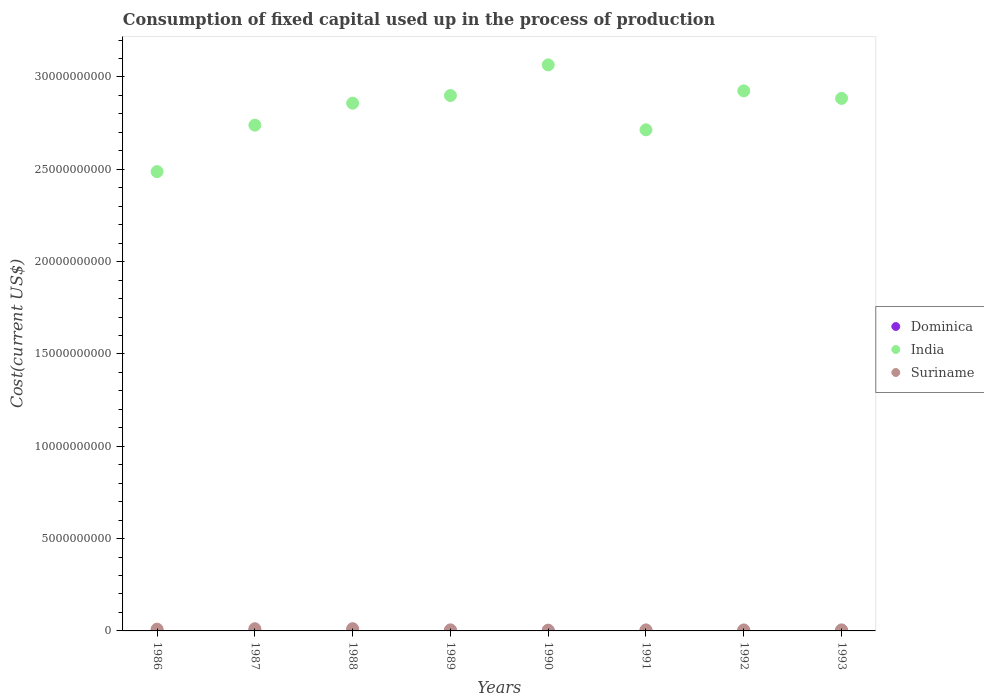How many different coloured dotlines are there?
Make the answer very short. 3. Is the number of dotlines equal to the number of legend labels?
Offer a very short reply. Yes. What is the amount consumed in the process of production in Suriname in 1989?
Your answer should be compact. 5.74e+07. Across all years, what is the maximum amount consumed in the process of production in Suriname?
Ensure brevity in your answer.  1.22e+08. Across all years, what is the minimum amount consumed in the process of production in Dominica?
Your answer should be compact. 4.17e+06. In which year was the amount consumed in the process of production in Suriname minimum?
Ensure brevity in your answer.  1990. What is the total amount consumed in the process of production in Dominica in the graph?
Your answer should be compact. 5.11e+07. What is the difference between the amount consumed in the process of production in India in 1990 and that in 1993?
Offer a terse response. 1.82e+09. What is the difference between the amount consumed in the process of production in India in 1986 and the amount consumed in the process of production in Suriname in 1990?
Give a very brief answer. 2.48e+1. What is the average amount consumed in the process of production in Dominica per year?
Your answer should be compact. 6.39e+06. In the year 1990, what is the difference between the amount consumed in the process of production in Suriname and amount consumed in the process of production in India?
Ensure brevity in your answer.  -3.06e+1. In how many years, is the amount consumed in the process of production in Suriname greater than 7000000000 US$?
Your response must be concise. 0. What is the ratio of the amount consumed in the process of production in Suriname in 1987 to that in 1992?
Provide a short and direct response. 2.21. What is the difference between the highest and the second highest amount consumed in the process of production in Dominica?
Ensure brevity in your answer.  5.16e+05. What is the difference between the highest and the lowest amount consumed in the process of production in Suriname?
Provide a short and direct response. 8.02e+07. Is it the case that in every year, the sum of the amount consumed in the process of production in Dominica and amount consumed in the process of production in India  is greater than the amount consumed in the process of production in Suriname?
Make the answer very short. Yes. Is the amount consumed in the process of production in India strictly greater than the amount consumed in the process of production in Suriname over the years?
Provide a short and direct response. Yes. Are the values on the major ticks of Y-axis written in scientific E-notation?
Make the answer very short. No. Does the graph contain grids?
Offer a terse response. No. Where does the legend appear in the graph?
Keep it short and to the point. Center right. How many legend labels are there?
Provide a succinct answer. 3. What is the title of the graph?
Offer a terse response. Consumption of fixed capital used up in the process of production. Does "Northern Mariana Islands" appear as one of the legend labels in the graph?
Offer a very short reply. No. What is the label or title of the X-axis?
Offer a very short reply. Years. What is the label or title of the Y-axis?
Your response must be concise. Cost(current US$). What is the Cost(current US$) of Dominica in 1986?
Your answer should be compact. 4.17e+06. What is the Cost(current US$) of India in 1986?
Offer a very short reply. 2.49e+1. What is the Cost(current US$) of Suriname in 1986?
Offer a terse response. 9.57e+07. What is the Cost(current US$) of Dominica in 1987?
Your answer should be compact. 4.59e+06. What is the Cost(current US$) in India in 1987?
Your response must be concise. 2.74e+1. What is the Cost(current US$) of Suriname in 1987?
Provide a short and direct response. 1.18e+08. What is the Cost(current US$) of Dominica in 1988?
Your answer should be very brief. 5.11e+06. What is the Cost(current US$) in India in 1988?
Your answer should be compact. 2.86e+1. What is the Cost(current US$) of Suriname in 1988?
Offer a terse response. 1.22e+08. What is the Cost(current US$) of Dominica in 1989?
Your answer should be compact. 5.78e+06. What is the Cost(current US$) of India in 1989?
Your answer should be compact. 2.90e+1. What is the Cost(current US$) of Suriname in 1989?
Make the answer very short. 5.74e+07. What is the Cost(current US$) in Dominica in 1990?
Provide a short and direct response. 6.67e+06. What is the Cost(current US$) in India in 1990?
Keep it short and to the point. 3.07e+1. What is the Cost(current US$) in Suriname in 1990?
Make the answer very short. 4.17e+07. What is the Cost(current US$) in Dominica in 1991?
Your answer should be very brief. 7.73e+06. What is the Cost(current US$) of India in 1991?
Provide a short and direct response. 2.71e+1. What is the Cost(current US$) in Suriname in 1991?
Give a very brief answer. 5.59e+07. What is the Cost(current US$) of Dominica in 1992?
Your response must be concise. 8.29e+06. What is the Cost(current US$) of India in 1992?
Keep it short and to the point. 2.92e+1. What is the Cost(current US$) of Suriname in 1992?
Offer a very short reply. 5.34e+07. What is the Cost(current US$) of Dominica in 1993?
Give a very brief answer. 8.80e+06. What is the Cost(current US$) in India in 1993?
Offer a very short reply. 2.88e+1. What is the Cost(current US$) of Suriname in 1993?
Your answer should be very brief. 5.61e+07. Across all years, what is the maximum Cost(current US$) in Dominica?
Ensure brevity in your answer.  8.80e+06. Across all years, what is the maximum Cost(current US$) of India?
Offer a very short reply. 3.07e+1. Across all years, what is the maximum Cost(current US$) of Suriname?
Provide a short and direct response. 1.22e+08. Across all years, what is the minimum Cost(current US$) in Dominica?
Provide a short and direct response. 4.17e+06. Across all years, what is the minimum Cost(current US$) in India?
Your answer should be very brief. 2.49e+1. Across all years, what is the minimum Cost(current US$) of Suriname?
Offer a very short reply. 4.17e+07. What is the total Cost(current US$) of Dominica in the graph?
Make the answer very short. 5.11e+07. What is the total Cost(current US$) of India in the graph?
Make the answer very short. 2.26e+11. What is the total Cost(current US$) in Suriname in the graph?
Keep it short and to the point. 6.00e+08. What is the difference between the Cost(current US$) of Dominica in 1986 and that in 1987?
Give a very brief answer. -4.29e+05. What is the difference between the Cost(current US$) of India in 1986 and that in 1987?
Offer a very short reply. -2.52e+09. What is the difference between the Cost(current US$) in Suriname in 1986 and that in 1987?
Give a very brief answer. -2.23e+07. What is the difference between the Cost(current US$) in Dominica in 1986 and that in 1988?
Your answer should be compact. -9.46e+05. What is the difference between the Cost(current US$) in India in 1986 and that in 1988?
Give a very brief answer. -3.71e+09. What is the difference between the Cost(current US$) in Suriname in 1986 and that in 1988?
Your response must be concise. -2.62e+07. What is the difference between the Cost(current US$) of Dominica in 1986 and that in 1989?
Provide a succinct answer. -1.61e+06. What is the difference between the Cost(current US$) of India in 1986 and that in 1989?
Make the answer very short. -4.12e+09. What is the difference between the Cost(current US$) of Suriname in 1986 and that in 1989?
Ensure brevity in your answer.  3.83e+07. What is the difference between the Cost(current US$) in Dominica in 1986 and that in 1990?
Your response must be concise. -2.50e+06. What is the difference between the Cost(current US$) of India in 1986 and that in 1990?
Your answer should be very brief. -5.78e+09. What is the difference between the Cost(current US$) in Suriname in 1986 and that in 1990?
Offer a very short reply. 5.40e+07. What is the difference between the Cost(current US$) of Dominica in 1986 and that in 1991?
Ensure brevity in your answer.  -3.56e+06. What is the difference between the Cost(current US$) of India in 1986 and that in 1991?
Your response must be concise. -2.26e+09. What is the difference between the Cost(current US$) in Suriname in 1986 and that in 1991?
Your answer should be very brief. 3.99e+07. What is the difference between the Cost(current US$) of Dominica in 1986 and that in 1992?
Your answer should be compact. -4.12e+06. What is the difference between the Cost(current US$) of India in 1986 and that in 1992?
Offer a very short reply. -4.37e+09. What is the difference between the Cost(current US$) of Suriname in 1986 and that in 1992?
Your answer should be very brief. 4.23e+07. What is the difference between the Cost(current US$) in Dominica in 1986 and that in 1993?
Keep it short and to the point. -4.64e+06. What is the difference between the Cost(current US$) of India in 1986 and that in 1993?
Offer a terse response. -3.97e+09. What is the difference between the Cost(current US$) in Suriname in 1986 and that in 1993?
Give a very brief answer. 3.97e+07. What is the difference between the Cost(current US$) in Dominica in 1987 and that in 1988?
Your answer should be very brief. -5.17e+05. What is the difference between the Cost(current US$) in India in 1987 and that in 1988?
Your response must be concise. -1.19e+09. What is the difference between the Cost(current US$) in Suriname in 1987 and that in 1988?
Make the answer very short. -3.94e+06. What is the difference between the Cost(current US$) in Dominica in 1987 and that in 1989?
Keep it short and to the point. -1.18e+06. What is the difference between the Cost(current US$) in India in 1987 and that in 1989?
Give a very brief answer. -1.60e+09. What is the difference between the Cost(current US$) in Suriname in 1987 and that in 1989?
Provide a succinct answer. 6.06e+07. What is the difference between the Cost(current US$) of Dominica in 1987 and that in 1990?
Keep it short and to the point. -2.07e+06. What is the difference between the Cost(current US$) in India in 1987 and that in 1990?
Give a very brief answer. -3.26e+09. What is the difference between the Cost(current US$) of Suriname in 1987 and that in 1990?
Your answer should be compact. 7.63e+07. What is the difference between the Cost(current US$) of Dominica in 1987 and that in 1991?
Offer a very short reply. -3.13e+06. What is the difference between the Cost(current US$) in India in 1987 and that in 1991?
Give a very brief answer. 2.53e+08. What is the difference between the Cost(current US$) of Suriname in 1987 and that in 1991?
Your answer should be very brief. 6.21e+07. What is the difference between the Cost(current US$) of Dominica in 1987 and that in 1992?
Offer a very short reply. -3.69e+06. What is the difference between the Cost(current US$) of India in 1987 and that in 1992?
Your answer should be very brief. -1.86e+09. What is the difference between the Cost(current US$) in Suriname in 1987 and that in 1992?
Ensure brevity in your answer.  6.46e+07. What is the difference between the Cost(current US$) in Dominica in 1987 and that in 1993?
Your response must be concise. -4.21e+06. What is the difference between the Cost(current US$) in India in 1987 and that in 1993?
Provide a short and direct response. -1.45e+09. What is the difference between the Cost(current US$) of Suriname in 1987 and that in 1993?
Keep it short and to the point. 6.19e+07. What is the difference between the Cost(current US$) in Dominica in 1988 and that in 1989?
Provide a short and direct response. -6.66e+05. What is the difference between the Cost(current US$) of India in 1988 and that in 1989?
Provide a succinct answer. -4.14e+08. What is the difference between the Cost(current US$) of Suriname in 1988 and that in 1989?
Provide a succinct answer. 6.45e+07. What is the difference between the Cost(current US$) of Dominica in 1988 and that in 1990?
Provide a succinct answer. -1.56e+06. What is the difference between the Cost(current US$) of India in 1988 and that in 1990?
Provide a short and direct response. -2.07e+09. What is the difference between the Cost(current US$) in Suriname in 1988 and that in 1990?
Give a very brief answer. 8.02e+07. What is the difference between the Cost(current US$) in Dominica in 1988 and that in 1991?
Your answer should be very brief. -2.61e+06. What is the difference between the Cost(current US$) in India in 1988 and that in 1991?
Provide a succinct answer. 1.44e+09. What is the difference between the Cost(current US$) of Suriname in 1988 and that in 1991?
Offer a terse response. 6.61e+07. What is the difference between the Cost(current US$) of Dominica in 1988 and that in 1992?
Provide a short and direct response. -3.17e+06. What is the difference between the Cost(current US$) in India in 1988 and that in 1992?
Provide a short and direct response. -6.66e+08. What is the difference between the Cost(current US$) of Suriname in 1988 and that in 1992?
Offer a terse response. 6.85e+07. What is the difference between the Cost(current US$) of Dominica in 1988 and that in 1993?
Provide a succinct answer. -3.69e+06. What is the difference between the Cost(current US$) in India in 1988 and that in 1993?
Keep it short and to the point. -2.58e+08. What is the difference between the Cost(current US$) in Suriname in 1988 and that in 1993?
Provide a succinct answer. 6.59e+07. What is the difference between the Cost(current US$) of Dominica in 1989 and that in 1990?
Provide a short and direct response. -8.90e+05. What is the difference between the Cost(current US$) in India in 1989 and that in 1990?
Make the answer very short. -1.66e+09. What is the difference between the Cost(current US$) in Suriname in 1989 and that in 1990?
Your answer should be compact. 1.57e+07. What is the difference between the Cost(current US$) in Dominica in 1989 and that in 1991?
Provide a succinct answer. -1.95e+06. What is the difference between the Cost(current US$) of India in 1989 and that in 1991?
Keep it short and to the point. 1.86e+09. What is the difference between the Cost(current US$) of Suriname in 1989 and that in 1991?
Your answer should be very brief. 1.56e+06. What is the difference between the Cost(current US$) of Dominica in 1989 and that in 1992?
Provide a short and direct response. -2.51e+06. What is the difference between the Cost(current US$) of India in 1989 and that in 1992?
Provide a succinct answer. -2.52e+08. What is the difference between the Cost(current US$) of Suriname in 1989 and that in 1992?
Provide a short and direct response. 4.01e+06. What is the difference between the Cost(current US$) of Dominica in 1989 and that in 1993?
Offer a very short reply. -3.02e+06. What is the difference between the Cost(current US$) of India in 1989 and that in 1993?
Your answer should be very brief. 1.55e+08. What is the difference between the Cost(current US$) of Suriname in 1989 and that in 1993?
Keep it short and to the point. 1.36e+06. What is the difference between the Cost(current US$) of Dominica in 1990 and that in 1991?
Your response must be concise. -1.06e+06. What is the difference between the Cost(current US$) of India in 1990 and that in 1991?
Ensure brevity in your answer.  3.52e+09. What is the difference between the Cost(current US$) of Suriname in 1990 and that in 1991?
Give a very brief answer. -1.41e+07. What is the difference between the Cost(current US$) in Dominica in 1990 and that in 1992?
Offer a terse response. -1.62e+06. What is the difference between the Cost(current US$) of India in 1990 and that in 1992?
Keep it short and to the point. 1.41e+09. What is the difference between the Cost(current US$) of Suriname in 1990 and that in 1992?
Make the answer very short. -1.17e+07. What is the difference between the Cost(current US$) of Dominica in 1990 and that in 1993?
Ensure brevity in your answer.  -2.13e+06. What is the difference between the Cost(current US$) in India in 1990 and that in 1993?
Provide a succinct answer. 1.82e+09. What is the difference between the Cost(current US$) in Suriname in 1990 and that in 1993?
Your answer should be very brief. -1.43e+07. What is the difference between the Cost(current US$) of Dominica in 1991 and that in 1992?
Give a very brief answer. -5.60e+05. What is the difference between the Cost(current US$) of India in 1991 and that in 1992?
Give a very brief answer. -2.11e+09. What is the difference between the Cost(current US$) in Suriname in 1991 and that in 1992?
Ensure brevity in your answer.  2.45e+06. What is the difference between the Cost(current US$) in Dominica in 1991 and that in 1993?
Keep it short and to the point. -1.08e+06. What is the difference between the Cost(current US$) in India in 1991 and that in 1993?
Make the answer very short. -1.70e+09. What is the difference between the Cost(current US$) in Suriname in 1991 and that in 1993?
Offer a very short reply. -1.99e+05. What is the difference between the Cost(current US$) in Dominica in 1992 and that in 1993?
Provide a succinct answer. -5.16e+05. What is the difference between the Cost(current US$) of India in 1992 and that in 1993?
Provide a succinct answer. 4.08e+08. What is the difference between the Cost(current US$) in Suriname in 1992 and that in 1993?
Your response must be concise. -2.65e+06. What is the difference between the Cost(current US$) of Dominica in 1986 and the Cost(current US$) of India in 1987?
Offer a terse response. -2.74e+1. What is the difference between the Cost(current US$) of Dominica in 1986 and the Cost(current US$) of Suriname in 1987?
Your response must be concise. -1.14e+08. What is the difference between the Cost(current US$) of India in 1986 and the Cost(current US$) of Suriname in 1987?
Make the answer very short. 2.48e+1. What is the difference between the Cost(current US$) in Dominica in 1986 and the Cost(current US$) in India in 1988?
Offer a terse response. -2.86e+1. What is the difference between the Cost(current US$) in Dominica in 1986 and the Cost(current US$) in Suriname in 1988?
Your response must be concise. -1.18e+08. What is the difference between the Cost(current US$) of India in 1986 and the Cost(current US$) of Suriname in 1988?
Provide a succinct answer. 2.48e+1. What is the difference between the Cost(current US$) in Dominica in 1986 and the Cost(current US$) in India in 1989?
Offer a very short reply. -2.90e+1. What is the difference between the Cost(current US$) in Dominica in 1986 and the Cost(current US$) in Suriname in 1989?
Your answer should be very brief. -5.33e+07. What is the difference between the Cost(current US$) in India in 1986 and the Cost(current US$) in Suriname in 1989?
Make the answer very short. 2.48e+1. What is the difference between the Cost(current US$) of Dominica in 1986 and the Cost(current US$) of India in 1990?
Offer a terse response. -3.07e+1. What is the difference between the Cost(current US$) in Dominica in 1986 and the Cost(current US$) in Suriname in 1990?
Ensure brevity in your answer.  -3.76e+07. What is the difference between the Cost(current US$) of India in 1986 and the Cost(current US$) of Suriname in 1990?
Provide a short and direct response. 2.48e+1. What is the difference between the Cost(current US$) of Dominica in 1986 and the Cost(current US$) of India in 1991?
Offer a very short reply. -2.71e+1. What is the difference between the Cost(current US$) in Dominica in 1986 and the Cost(current US$) in Suriname in 1991?
Provide a short and direct response. -5.17e+07. What is the difference between the Cost(current US$) of India in 1986 and the Cost(current US$) of Suriname in 1991?
Offer a very short reply. 2.48e+1. What is the difference between the Cost(current US$) in Dominica in 1986 and the Cost(current US$) in India in 1992?
Your answer should be very brief. -2.92e+1. What is the difference between the Cost(current US$) of Dominica in 1986 and the Cost(current US$) of Suriname in 1992?
Make the answer very short. -4.93e+07. What is the difference between the Cost(current US$) of India in 1986 and the Cost(current US$) of Suriname in 1992?
Provide a short and direct response. 2.48e+1. What is the difference between the Cost(current US$) in Dominica in 1986 and the Cost(current US$) in India in 1993?
Provide a short and direct response. -2.88e+1. What is the difference between the Cost(current US$) of Dominica in 1986 and the Cost(current US$) of Suriname in 1993?
Ensure brevity in your answer.  -5.19e+07. What is the difference between the Cost(current US$) in India in 1986 and the Cost(current US$) in Suriname in 1993?
Ensure brevity in your answer.  2.48e+1. What is the difference between the Cost(current US$) of Dominica in 1987 and the Cost(current US$) of India in 1988?
Make the answer very short. -2.86e+1. What is the difference between the Cost(current US$) in Dominica in 1987 and the Cost(current US$) in Suriname in 1988?
Make the answer very short. -1.17e+08. What is the difference between the Cost(current US$) in India in 1987 and the Cost(current US$) in Suriname in 1988?
Your answer should be very brief. 2.73e+1. What is the difference between the Cost(current US$) of Dominica in 1987 and the Cost(current US$) of India in 1989?
Your answer should be very brief. -2.90e+1. What is the difference between the Cost(current US$) of Dominica in 1987 and the Cost(current US$) of Suriname in 1989?
Offer a very short reply. -5.29e+07. What is the difference between the Cost(current US$) in India in 1987 and the Cost(current US$) in Suriname in 1989?
Provide a succinct answer. 2.73e+1. What is the difference between the Cost(current US$) of Dominica in 1987 and the Cost(current US$) of India in 1990?
Keep it short and to the point. -3.07e+1. What is the difference between the Cost(current US$) in Dominica in 1987 and the Cost(current US$) in Suriname in 1990?
Ensure brevity in your answer.  -3.71e+07. What is the difference between the Cost(current US$) in India in 1987 and the Cost(current US$) in Suriname in 1990?
Make the answer very short. 2.73e+1. What is the difference between the Cost(current US$) of Dominica in 1987 and the Cost(current US$) of India in 1991?
Provide a short and direct response. -2.71e+1. What is the difference between the Cost(current US$) in Dominica in 1987 and the Cost(current US$) in Suriname in 1991?
Give a very brief answer. -5.13e+07. What is the difference between the Cost(current US$) of India in 1987 and the Cost(current US$) of Suriname in 1991?
Offer a very short reply. 2.73e+1. What is the difference between the Cost(current US$) of Dominica in 1987 and the Cost(current US$) of India in 1992?
Provide a succinct answer. -2.92e+1. What is the difference between the Cost(current US$) in Dominica in 1987 and the Cost(current US$) in Suriname in 1992?
Give a very brief answer. -4.88e+07. What is the difference between the Cost(current US$) in India in 1987 and the Cost(current US$) in Suriname in 1992?
Provide a succinct answer. 2.73e+1. What is the difference between the Cost(current US$) of Dominica in 1987 and the Cost(current US$) of India in 1993?
Your answer should be compact. -2.88e+1. What is the difference between the Cost(current US$) of Dominica in 1987 and the Cost(current US$) of Suriname in 1993?
Ensure brevity in your answer.  -5.15e+07. What is the difference between the Cost(current US$) in India in 1987 and the Cost(current US$) in Suriname in 1993?
Your answer should be very brief. 2.73e+1. What is the difference between the Cost(current US$) in Dominica in 1988 and the Cost(current US$) in India in 1989?
Give a very brief answer. -2.90e+1. What is the difference between the Cost(current US$) of Dominica in 1988 and the Cost(current US$) of Suriname in 1989?
Give a very brief answer. -5.23e+07. What is the difference between the Cost(current US$) of India in 1988 and the Cost(current US$) of Suriname in 1989?
Ensure brevity in your answer.  2.85e+1. What is the difference between the Cost(current US$) of Dominica in 1988 and the Cost(current US$) of India in 1990?
Your answer should be very brief. -3.07e+1. What is the difference between the Cost(current US$) in Dominica in 1988 and the Cost(current US$) in Suriname in 1990?
Your response must be concise. -3.66e+07. What is the difference between the Cost(current US$) of India in 1988 and the Cost(current US$) of Suriname in 1990?
Offer a very short reply. 2.85e+1. What is the difference between the Cost(current US$) in Dominica in 1988 and the Cost(current US$) in India in 1991?
Give a very brief answer. -2.71e+1. What is the difference between the Cost(current US$) of Dominica in 1988 and the Cost(current US$) of Suriname in 1991?
Your answer should be very brief. -5.08e+07. What is the difference between the Cost(current US$) of India in 1988 and the Cost(current US$) of Suriname in 1991?
Provide a short and direct response. 2.85e+1. What is the difference between the Cost(current US$) of Dominica in 1988 and the Cost(current US$) of India in 1992?
Your answer should be compact. -2.92e+1. What is the difference between the Cost(current US$) in Dominica in 1988 and the Cost(current US$) in Suriname in 1992?
Ensure brevity in your answer.  -4.83e+07. What is the difference between the Cost(current US$) in India in 1988 and the Cost(current US$) in Suriname in 1992?
Give a very brief answer. 2.85e+1. What is the difference between the Cost(current US$) in Dominica in 1988 and the Cost(current US$) in India in 1993?
Keep it short and to the point. -2.88e+1. What is the difference between the Cost(current US$) of Dominica in 1988 and the Cost(current US$) of Suriname in 1993?
Your response must be concise. -5.10e+07. What is the difference between the Cost(current US$) of India in 1988 and the Cost(current US$) of Suriname in 1993?
Keep it short and to the point. 2.85e+1. What is the difference between the Cost(current US$) of Dominica in 1989 and the Cost(current US$) of India in 1990?
Provide a succinct answer. -3.07e+1. What is the difference between the Cost(current US$) of Dominica in 1989 and the Cost(current US$) of Suriname in 1990?
Offer a terse response. -3.60e+07. What is the difference between the Cost(current US$) of India in 1989 and the Cost(current US$) of Suriname in 1990?
Offer a very short reply. 2.90e+1. What is the difference between the Cost(current US$) in Dominica in 1989 and the Cost(current US$) in India in 1991?
Make the answer very short. -2.71e+1. What is the difference between the Cost(current US$) of Dominica in 1989 and the Cost(current US$) of Suriname in 1991?
Provide a short and direct response. -5.01e+07. What is the difference between the Cost(current US$) in India in 1989 and the Cost(current US$) in Suriname in 1991?
Your answer should be very brief. 2.89e+1. What is the difference between the Cost(current US$) in Dominica in 1989 and the Cost(current US$) in India in 1992?
Ensure brevity in your answer.  -2.92e+1. What is the difference between the Cost(current US$) of Dominica in 1989 and the Cost(current US$) of Suriname in 1992?
Provide a short and direct response. -4.77e+07. What is the difference between the Cost(current US$) in India in 1989 and the Cost(current US$) in Suriname in 1992?
Your answer should be very brief. 2.89e+1. What is the difference between the Cost(current US$) in Dominica in 1989 and the Cost(current US$) in India in 1993?
Provide a succinct answer. -2.88e+1. What is the difference between the Cost(current US$) of Dominica in 1989 and the Cost(current US$) of Suriname in 1993?
Your answer should be very brief. -5.03e+07. What is the difference between the Cost(current US$) of India in 1989 and the Cost(current US$) of Suriname in 1993?
Your answer should be very brief. 2.89e+1. What is the difference between the Cost(current US$) of Dominica in 1990 and the Cost(current US$) of India in 1991?
Provide a succinct answer. -2.71e+1. What is the difference between the Cost(current US$) in Dominica in 1990 and the Cost(current US$) in Suriname in 1991?
Your answer should be very brief. -4.92e+07. What is the difference between the Cost(current US$) of India in 1990 and the Cost(current US$) of Suriname in 1991?
Offer a very short reply. 3.06e+1. What is the difference between the Cost(current US$) of Dominica in 1990 and the Cost(current US$) of India in 1992?
Your answer should be very brief. -2.92e+1. What is the difference between the Cost(current US$) in Dominica in 1990 and the Cost(current US$) in Suriname in 1992?
Give a very brief answer. -4.68e+07. What is the difference between the Cost(current US$) of India in 1990 and the Cost(current US$) of Suriname in 1992?
Your answer should be very brief. 3.06e+1. What is the difference between the Cost(current US$) in Dominica in 1990 and the Cost(current US$) in India in 1993?
Give a very brief answer. -2.88e+1. What is the difference between the Cost(current US$) in Dominica in 1990 and the Cost(current US$) in Suriname in 1993?
Keep it short and to the point. -4.94e+07. What is the difference between the Cost(current US$) of India in 1990 and the Cost(current US$) of Suriname in 1993?
Keep it short and to the point. 3.06e+1. What is the difference between the Cost(current US$) in Dominica in 1991 and the Cost(current US$) in India in 1992?
Offer a very short reply. -2.92e+1. What is the difference between the Cost(current US$) of Dominica in 1991 and the Cost(current US$) of Suriname in 1992?
Offer a terse response. -4.57e+07. What is the difference between the Cost(current US$) of India in 1991 and the Cost(current US$) of Suriname in 1992?
Keep it short and to the point. 2.71e+1. What is the difference between the Cost(current US$) of Dominica in 1991 and the Cost(current US$) of India in 1993?
Provide a succinct answer. -2.88e+1. What is the difference between the Cost(current US$) in Dominica in 1991 and the Cost(current US$) in Suriname in 1993?
Provide a succinct answer. -4.84e+07. What is the difference between the Cost(current US$) of India in 1991 and the Cost(current US$) of Suriname in 1993?
Ensure brevity in your answer.  2.71e+1. What is the difference between the Cost(current US$) in Dominica in 1992 and the Cost(current US$) in India in 1993?
Your answer should be compact. -2.88e+1. What is the difference between the Cost(current US$) of Dominica in 1992 and the Cost(current US$) of Suriname in 1993?
Make the answer very short. -4.78e+07. What is the difference between the Cost(current US$) in India in 1992 and the Cost(current US$) in Suriname in 1993?
Ensure brevity in your answer.  2.92e+1. What is the average Cost(current US$) of Dominica per year?
Ensure brevity in your answer.  6.39e+06. What is the average Cost(current US$) of India per year?
Provide a short and direct response. 2.82e+1. What is the average Cost(current US$) of Suriname per year?
Your response must be concise. 7.50e+07. In the year 1986, what is the difference between the Cost(current US$) in Dominica and Cost(current US$) in India?
Keep it short and to the point. -2.49e+1. In the year 1986, what is the difference between the Cost(current US$) in Dominica and Cost(current US$) in Suriname?
Your answer should be compact. -9.16e+07. In the year 1986, what is the difference between the Cost(current US$) in India and Cost(current US$) in Suriname?
Your answer should be very brief. 2.48e+1. In the year 1987, what is the difference between the Cost(current US$) of Dominica and Cost(current US$) of India?
Your answer should be very brief. -2.74e+1. In the year 1987, what is the difference between the Cost(current US$) in Dominica and Cost(current US$) in Suriname?
Make the answer very short. -1.13e+08. In the year 1987, what is the difference between the Cost(current US$) in India and Cost(current US$) in Suriname?
Offer a very short reply. 2.73e+1. In the year 1988, what is the difference between the Cost(current US$) in Dominica and Cost(current US$) in India?
Your answer should be very brief. -2.86e+1. In the year 1988, what is the difference between the Cost(current US$) in Dominica and Cost(current US$) in Suriname?
Your answer should be compact. -1.17e+08. In the year 1988, what is the difference between the Cost(current US$) in India and Cost(current US$) in Suriname?
Offer a very short reply. 2.85e+1. In the year 1989, what is the difference between the Cost(current US$) of Dominica and Cost(current US$) of India?
Provide a short and direct response. -2.90e+1. In the year 1989, what is the difference between the Cost(current US$) of Dominica and Cost(current US$) of Suriname?
Offer a very short reply. -5.17e+07. In the year 1989, what is the difference between the Cost(current US$) in India and Cost(current US$) in Suriname?
Make the answer very short. 2.89e+1. In the year 1990, what is the difference between the Cost(current US$) in Dominica and Cost(current US$) in India?
Your answer should be very brief. -3.06e+1. In the year 1990, what is the difference between the Cost(current US$) in Dominica and Cost(current US$) in Suriname?
Make the answer very short. -3.51e+07. In the year 1990, what is the difference between the Cost(current US$) in India and Cost(current US$) in Suriname?
Give a very brief answer. 3.06e+1. In the year 1991, what is the difference between the Cost(current US$) in Dominica and Cost(current US$) in India?
Your response must be concise. -2.71e+1. In the year 1991, what is the difference between the Cost(current US$) in Dominica and Cost(current US$) in Suriname?
Ensure brevity in your answer.  -4.82e+07. In the year 1991, what is the difference between the Cost(current US$) in India and Cost(current US$) in Suriname?
Your answer should be very brief. 2.71e+1. In the year 1992, what is the difference between the Cost(current US$) in Dominica and Cost(current US$) in India?
Your response must be concise. -2.92e+1. In the year 1992, what is the difference between the Cost(current US$) of Dominica and Cost(current US$) of Suriname?
Your response must be concise. -4.51e+07. In the year 1992, what is the difference between the Cost(current US$) in India and Cost(current US$) in Suriname?
Your answer should be compact. 2.92e+1. In the year 1993, what is the difference between the Cost(current US$) of Dominica and Cost(current US$) of India?
Provide a short and direct response. -2.88e+1. In the year 1993, what is the difference between the Cost(current US$) of Dominica and Cost(current US$) of Suriname?
Provide a short and direct response. -4.73e+07. In the year 1993, what is the difference between the Cost(current US$) of India and Cost(current US$) of Suriname?
Make the answer very short. 2.88e+1. What is the ratio of the Cost(current US$) in Dominica in 1986 to that in 1987?
Offer a terse response. 0.91. What is the ratio of the Cost(current US$) of India in 1986 to that in 1987?
Provide a succinct answer. 0.91. What is the ratio of the Cost(current US$) of Suriname in 1986 to that in 1987?
Ensure brevity in your answer.  0.81. What is the ratio of the Cost(current US$) of Dominica in 1986 to that in 1988?
Your answer should be compact. 0.81. What is the ratio of the Cost(current US$) of India in 1986 to that in 1988?
Give a very brief answer. 0.87. What is the ratio of the Cost(current US$) of Suriname in 1986 to that in 1988?
Make the answer very short. 0.79. What is the ratio of the Cost(current US$) of Dominica in 1986 to that in 1989?
Offer a terse response. 0.72. What is the ratio of the Cost(current US$) of India in 1986 to that in 1989?
Provide a short and direct response. 0.86. What is the ratio of the Cost(current US$) of Suriname in 1986 to that in 1989?
Offer a terse response. 1.67. What is the ratio of the Cost(current US$) of Dominica in 1986 to that in 1990?
Give a very brief answer. 0.62. What is the ratio of the Cost(current US$) in India in 1986 to that in 1990?
Give a very brief answer. 0.81. What is the ratio of the Cost(current US$) in Suriname in 1986 to that in 1990?
Provide a short and direct response. 2.29. What is the ratio of the Cost(current US$) of Dominica in 1986 to that in 1991?
Your response must be concise. 0.54. What is the ratio of the Cost(current US$) in India in 1986 to that in 1991?
Ensure brevity in your answer.  0.92. What is the ratio of the Cost(current US$) of Suriname in 1986 to that in 1991?
Your answer should be very brief. 1.71. What is the ratio of the Cost(current US$) of Dominica in 1986 to that in 1992?
Ensure brevity in your answer.  0.5. What is the ratio of the Cost(current US$) in India in 1986 to that in 1992?
Ensure brevity in your answer.  0.85. What is the ratio of the Cost(current US$) in Suriname in 1986 to that in 1992?
Your answer should be very brief. 1.79. What is the ratio of the Cost(current US$) in Dominica in 1986 to that in 1993?
Make the answer very short. 0.47. What is the ratio of the Cost(current US$) of India in 1986 to that in 1993?
Your response must be concise. 0.86. What is the ratio of the Cost(current US$) of Suriname in 1986 to that in 1993?
Your response must be concise. 1.71. What is the ratio of the Cost(current US$) in Dominica in 1987 to that in 1988?
Offer a terse response. 0.9. What is the ratio of the Cost(current US$) in India in 1987 to that in 1988?
Give a very brief answer. 0.96. What is the ratio of the Cost(current US$) in Suriname in 1987 to that in 1988?
Offer a terse response. 0.97. What is the ratio of the Cost(current US$) of Dominica in 1987 to that in 1989?
Offer a terse response. 0.8. What is the ratio of the Cost(current US$) in India in 1987 to that in 1989?
Offer a very short reply. 0.94. What is the ratio of the Cost(current US$) in Suriname in 1987 to that in 1989?
Offer a very short reply. 2.05. What is the ratio of the Cost(current US$) in Dominica in 1987 to that in 1990?
Provide a short and direct response. 0.69. What is the ratio of the Cost(current US$) of India in 1987 to that in 1990?
Ensure brevity in your answer.  0.89. What is the ratio of the Cost(current US$) in Suriname in 1987 to that in 1990?
Ensure brevity in your answer.  2.83. What is the ratio of the Cost(current US$) of Dominica in 1987 to that in 1991?
Make the answer very short. 0.59. What is the ratio of the Cost(current US$) in India in 1987 to that in 1991?
Provide a succinct answer. 1.01. What is the ratio of the Cost(current US$) in Suriname in 1987 to that in 1991?
Offer a very short reply. 2.11. What is the ratio of the Cost(current US$) of Dominica in 1987 to that in 1992?
Your response must be concise. 0.55. What is the ratio of the Cost(current US$) in India in 1987 to that in 1992?
Give a very brief answer. 0.94. What is the ratio of the Cost(current US$) of Suriname in 1987 to that in 1992?
Offer a very short reply. 2.21. What is the ratio of the Cost(current US$) in Dominica in 1987 to that in 1993?
Your response must be concise. 0.52. What is the ratio of the Cost(current US$) of India in 1987 to that in 1993?
Offer a very short reply. 0.95. What is the ratio of the Cost(current US$) in Suriname in 1987 to that in 1993?
Provide a short and direct response. 2.1. What is the ratio of the Cost(current US$) of Dominica in 1988 to that in 1989?
Give a very brief answer. 0.88. What is the ratio of the Cost(current US$) of India in 1988 to that in 1989?
Make the answer very short. 0.99. What is the ratio of the Cost(current US$) of Suriname in 1988 to that in 1989?
Provide a succinct answer. 2.12. What is the ratio of the Cost(current US$) of Dominica in 1988 to that in 1990?
Provide a succinct answer. 0.77. What is the ratio of the Cost(current US$) of India in 1988 to that in 1990?
Ensure brevity in your answer.  0.93. What is the ratio of the Cost(current US$) of Suriname in 1988 to that in 1990?
Keep it short and to the point. 2.92. What is the ratio of the Cost(current US$) of Dominica in 1988 to that in 1991?
Your answer should be very brief. 0.66. What is the ratio of the Cost(current US$) in India in 1988 to that in 1991?
Keep it short and to the point. 1.05. What is the ratio of the Cost(current US$) of Suriname in 1988 to that in 1991?
Your response must be concise. 2.18. What is the ratio of the Cost(current US$) of Dominica in 1988 to that in 1992?
Make the answer very short. 0.62. What is the ratio of the Cost(current US$) in India in 1988 to that in 1992?
Offer a very short reply. 0.98. What is the ratio of the Cost(current US$) of Suriname in 1988 to that in 1992?
Keep it short and to the point. 2.28. What is the ratio of the Cost(current US$) in Dominica in 1988 to that in 1993?
Keep it short and to the point. 0.58. What is the ratio of the Cost(current US$) of Suriname in 1988 to that in 1993?
Keep it short and to the point. 2.17. What is the ratio of the Cost(current US$) of Dominica in 1989 to that in 1990?
Ensure brevity in your answer.  0.87. What is the ratio of the Cost(current US$) in India in 1989 to that in 1990?
Your answer should be very brief. 0.95. What is the ratio of the Cost(current US$) in Suriname in 1989 to that in 1990?
Offer a very short reply. 1.38. What is the ratio of the Cost(current US$) in Dominica in 1989 to that in 1991?
Provide a short and direct response. 0.75. What is the ratio of the Cost(current US$) in India in 1989 to that in 1991?
Offer a terse response. 1.07. What is the ratio of the Cost(current US$) of Suriname in 1989 to that in 1991?
Your response must be concise. 1.03. What is the ratio of the Cost(current US$) in Dominica in 1989 to that in 1992?
Ensure brevity in your answer.  0.7. What is the ratio of the Cost(current US$) in Suriname in 1989 to that in 1992?
Make the answer very short. 1.08. What is the ratio of the Cost(current US$) of Dominica in 1989 to that in 1993?
Your answer should be compact. 0.66. What is the ratio of the Cost(current US$) in India in 1989 to that in 1993?
Your answer should be very brief. 1.01. What is the ratio of the Cost(current US$) in Suriname in 1989 to that in 1993?
Give a very brief answer. 1.02. What is the ratio of the Cost(current US$) of Dominica in 1990 to that in 1991?
Make the answer very short. 0.86. What is the ratio of the Cost(current US$) of India in 1990 to that in 1991?
Offer a very short reply. 1.13. What is the ratio of the Cost(current US$) in Suriname in 1990 to that in 1991?
Offer a terse response. 0.75. What is the ratio of the Cost(current US$) in Dominica in 1990 to that in 1992?
Offer a very short reply. 0.8. What is the ratio of the Cost(current US$) of India in 1990 to that in 1992?
Give a very brief answer. 1.05. What is the ratio of the Cost(current US$) in Suriname in 1990 to that in 1992?
Your answer should be very brief. 0.78. What is the ratio of the Cost(current US$) in Dominica in 1990 to that in 1993?
Offer a terse response. 0.76. What is the ratio of the Cost(current US$) of India in 1990 to that in 1993?
Offer a very short reply. 1.06. What is the ratio of the Cost(current US$) of Suriname in 1990 to that in 1993?
Provide a short and direct response. 0.74. What is the ratio of the Cost(current US$) in Dominica in 1991 to that in 1992?
Give a very brief answer. 0.93. What is the ratio of the Cost(current US$) in India in 1991 to that in 1992?
Make the answer very short. 0.93. What is the ratio of the Cost(current US$) in Suriname in 1991 to that in 1992?
Give a very brief answer. 1.05. What is the ratio of the Cost(current US$) of Dominica in 1991 to that in 1993?
Offer a very short reply. 0.88. What is the ratio of the Cost(current US$) of India in 1991 to that in 1993?
Provide a short and direct response. 0.94. What is the ratio of the Cost(current US$) in Suriname in 1991 to that in 1993?
Provide a succinct answer. 1. What is the ratio of the Cost(current US$) in Dominica in 1992 to that in 1993?
Provide a succinct answer. 0.94. What is the ratio of the Cost(current US$) of India in 1992 to that in 1993?
Ensure brevity in your answer.  1.01. What is the ratio of the Cost(current US$) in Suriname in 1992 to that in 1993?
Offer a very short reply. 0.95. What is the difference between the highest and the second highest Cost(current US$) of Dominica?
Give a very brief answer. 5.16e+05. What is the difference between the highest and the second highest Cost(current US$) of India?
Provide a short and direct response. 1.41e+09. What is the difference between the highest and the second highest Cost(current US$) of Suriname?
Offer a very short reply. 3.94e+06. What is the difference between the highest and the lowest Cost(current US$) of Dominica?
Offer a very short reply. 4.64e+06. What is the difference between the highest and the lowest Cost(current US$) of India?
Give a very brief answer. 5.78e+09. What is the difference between the highest and the lowest Cost(current US$) in Suriname?
Ensure brevity in your answer.  8.02e+07. 